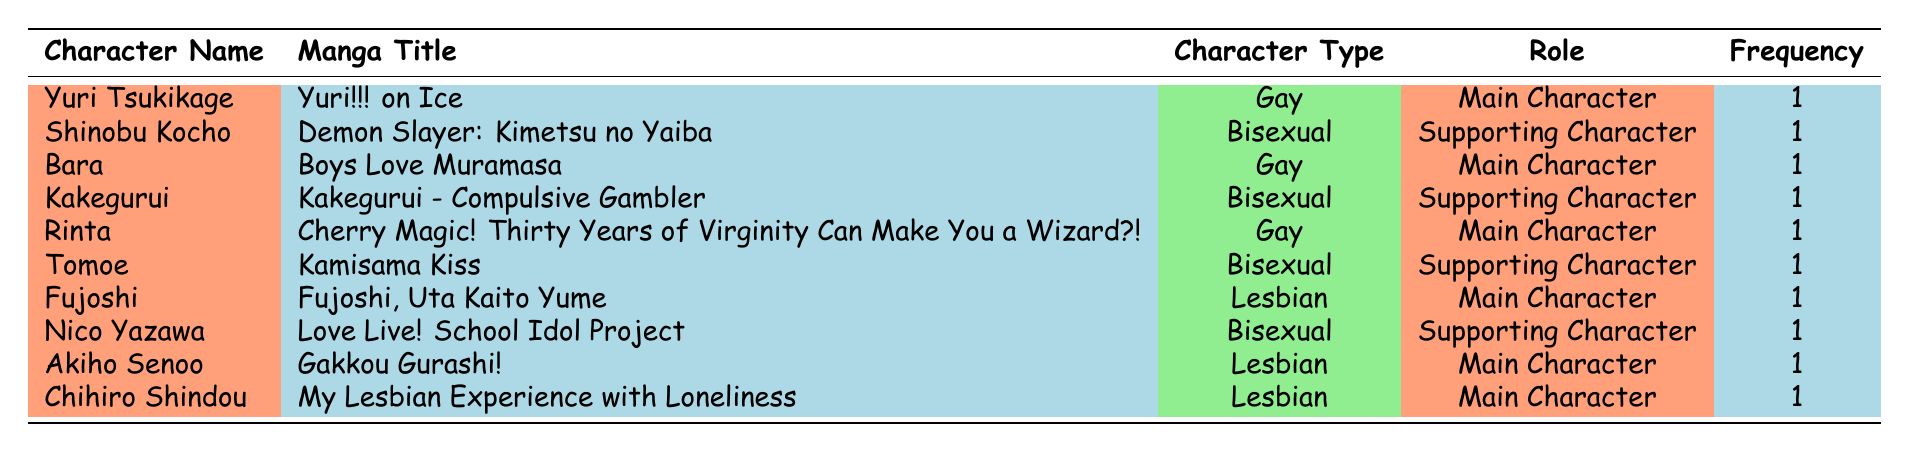What is the character type of Rinta? Referring to the table, Rinta is listed under the "Character Type" column, which states "Gay".
Answer: Gay How many main characters are LGBTQ+ in these mangas? By scanning the "Role" column, there are four main characters: Yuri Tsukikage, Bara, Rinta, and Fujoshi, Akiho Senoo, and Chihiro Shindou. Therefore, the total number of main characters is 5.
Answer: 5 Is there a bisexual character in "Kakegurui - Compulsive Gambler"? According to the table, Kakegurui has a character listed as "Kakegurui" who is described as Bisexual, confirming the presence of a bisexual character in this manga.
Answer: Yes Which manga features a lesbian main character? According to the table, "Fujoshi, Uta Kaito Yume", "Gakkou Gurashi!" and "My Lesbian Experience with Loneliness" all have lesbian main characters: Fujoshi, Akiho Senoo, and Chihiro Shindou. Hence, there are three such mangas.
Answer: 3 What percentage of the characters are bisexual? There are three bisexual characters (Shinobu Kocho, Kakegurui, and Tomoe) out of a total of ten characters. To find the percentage, compute (3/10) * 100 = 30%.
Answer: 30% How many supporting characters are LGBTQ+? By reviewing the "Role" column, it states that there are four supporting characters: Shinobu Kocho, Kakegurui, Tomoe, and Nico Yazawa, leading to a total of 4 supporting characters.
Answer: 4 Which type has the highest frequency among LGBTQ+ characters? By comparing counts, gay characters appear three times (Yuri Tsukikage, Bara, Rinta), bisexual appears three times (Shinobu Kocho, Kakegurui, Tomoe, Nico Yazawa), and lesbian character appears four times (Fujoshi, Akiho Senoo, Chihiro Shindou). The highest frequency type is Lesbian.
Answer: Lesbian Does "Demon Slayer: Kimetsu no Yaiba" have a main character who is LGBTQ+? In the table, the role for Shinobu Kocho is listed under "Supporting Character", and since it is not a main character, the answer is negative.
Answer: No 